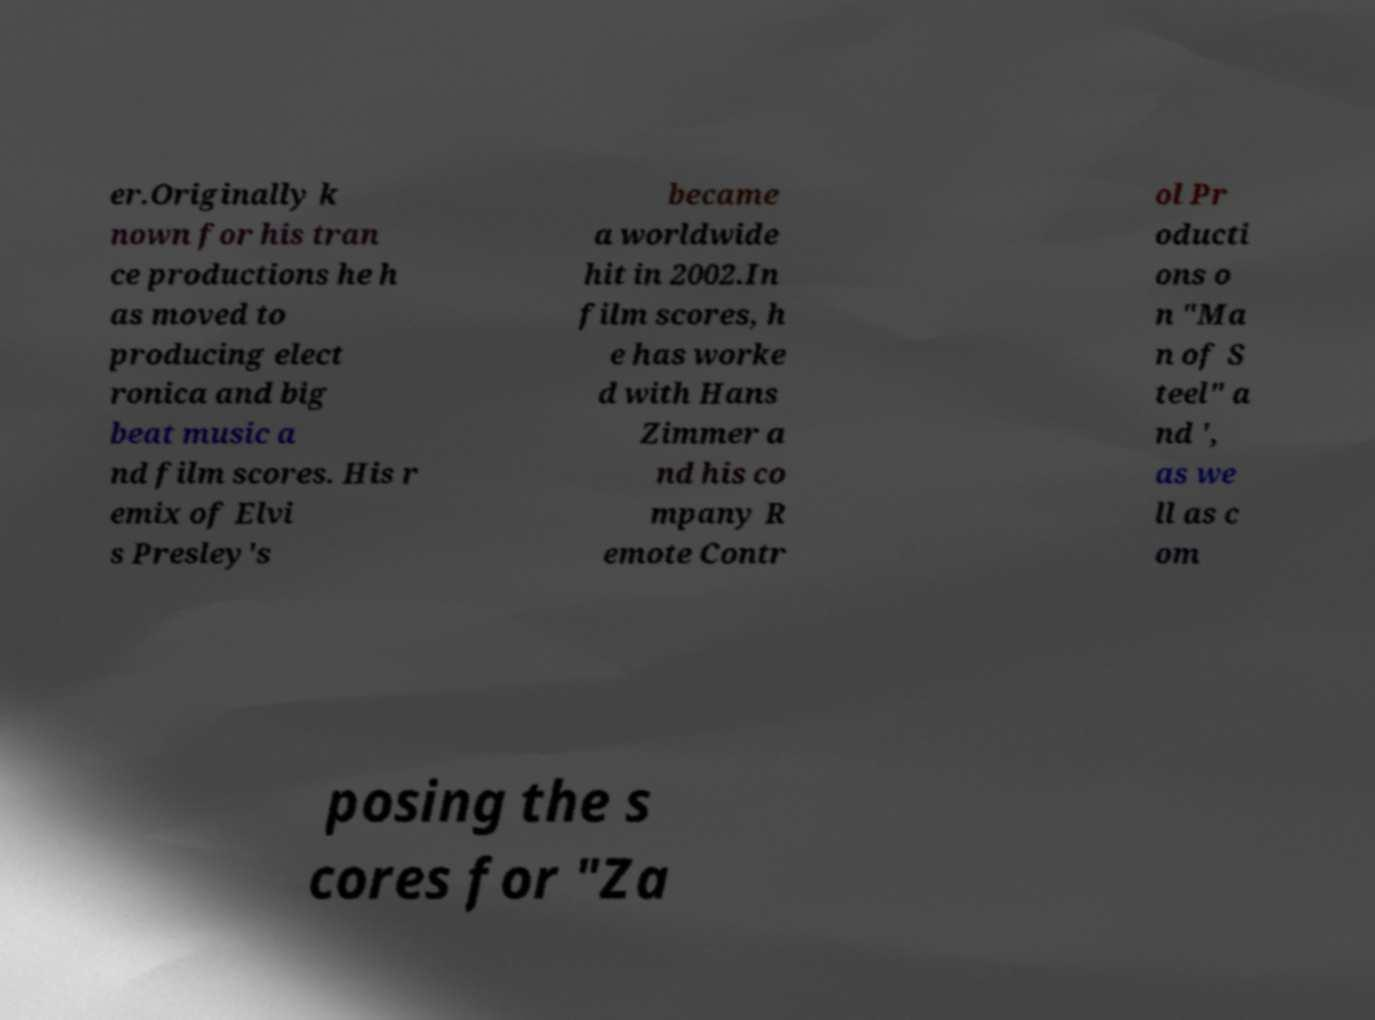For documentation purposes, I need the text within this image transcribed. Could you provide that? er.Originally k nown for his tran ce productions he h as moved to producing elect ronica and big beat music a nd film scores. His r emix of Elvi s Presley's became a worldwide hit in 2002.In film scores, h e has worke d with Hans Zimmer a nd his co mpany R emote Contr ol Pr oducti ons o n "Ma n of S teel" a nd ', as we ll as c om posing the s cores for "Za 